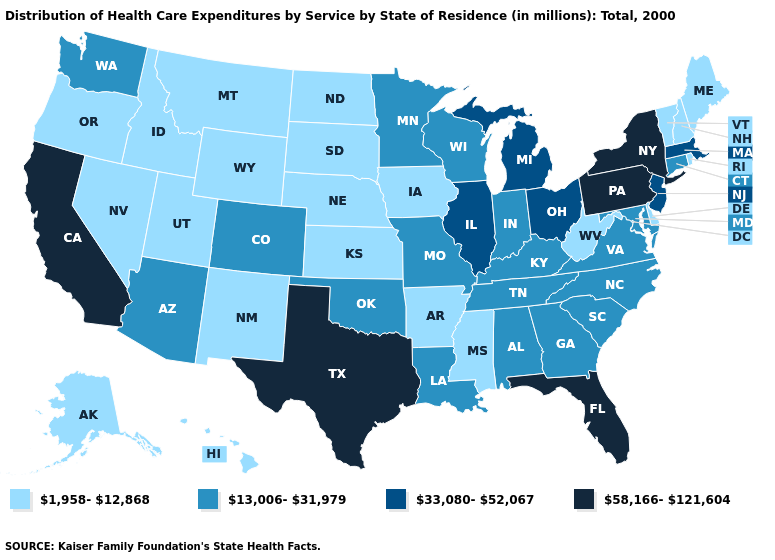Name the states that have a value in the range 1,958-12,868?
Short answer required. Alaska, Arkansas, Delaware, Hawaii, Idaho, Iowa, Kansas, Maine, Mississippi, Montana, Nebraska, Nevada, New Hampshire, New Mexico, North Dakota, Oregon, Rhode Island, South Dakota, Utah, Vermont, West Virginia, Wyoming. Among the states that border Oklahoma , does Texas have the highest value?
Write a very short answer. Yes. Does Rhode Island have the lowest value in the Northeast?
Quick response, please. Yes. Name the states that have a value in the range 33,080-52,067?
Keep it brief. Illinois, Massachusetts, Michigan, New Jersey, Ohio. Which states have the lowest value in the USA?
Write a very short answer. Alaska, Arkansas, Delaware, Hawaii, Idaho, Iowa, Kansas, Maine, Mississippi, Montana, Nebraska, Nevada, New Hampshire, New Mexico, North Dakota, Oregon, Rhode Island, South Dakota, Utah, Vermont, West Virginia, Wyoming. Which states hav the highest value in the South?
Short answer required. Florida, Texas. Name the states that have a value in the range 13,006-31,979?
Write a very short answer. Alabama, Arizona, Colorado, Connecticut, Georgia, Indiana, Kentucky, Louisiana, Maryland, Minnesota, Missouri, North Carolina, Oklahoma, South Carolina, Tennessee, Virginia, Washington, Wisconsin. What is the highest value in states that border Missouri?
Be succinct. 33,080-52,067. Does Illinois have the same value as Minnesota?
Write a very short answer. No. Does Texas have the highest value in the USA?
Answer briefly. Yes. Does Connecticut have a lower value than Nevada?
Quick response, please. No. What is the value of Indiana?
Write a very short answer. 13,006-31,979. What is the value of Arkansas?
Write a very short answer. 1,958-12,868. Does the map have missing data?
Give a very brief answer. No. What is the lowest value in the Northeast?
Be succinct. 1,958-12,868. 